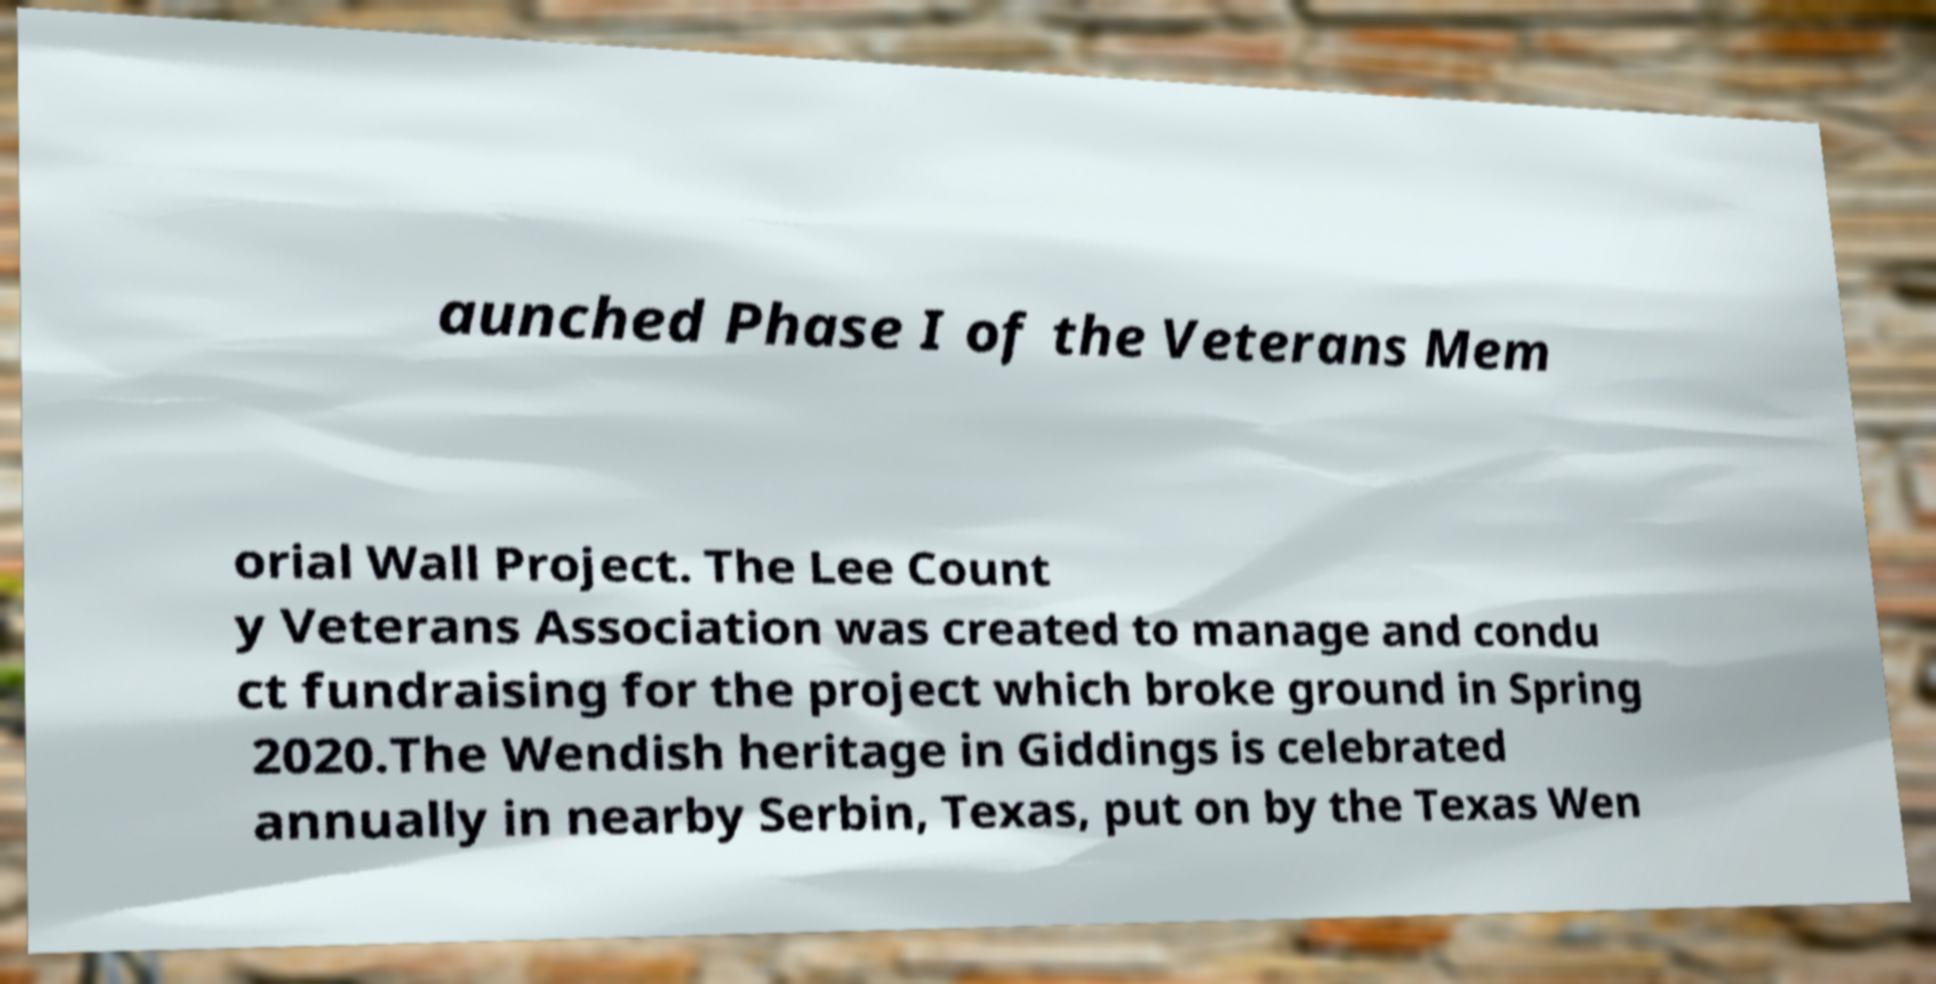Could you extract and type out the text from this image? aunched Phase I of the Veterans Mem orial Wall Project. The Lee Count y Veterans Association was created to manage and condu ct fundraising for the project which broke ground in Spring 2020.The Wendish heritage in Giddings is celebrated annually in nearby Serbin, Texas, put on by the Texas Wen 